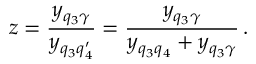<formula> <loc_0><loc_0><loc_500><loc_500>z = \frac { y _ { q _ { 3 } \gamma } } { y _ { q _ { 3 } q _ { 4 } ^ { \prime } } } = \frac { y _ { q _ { 3 } \gamma } } { y _ { q _ { 3 } q _ { 4 } } + y _ { q _ { 3 } \gamma } } \, .</formula> 